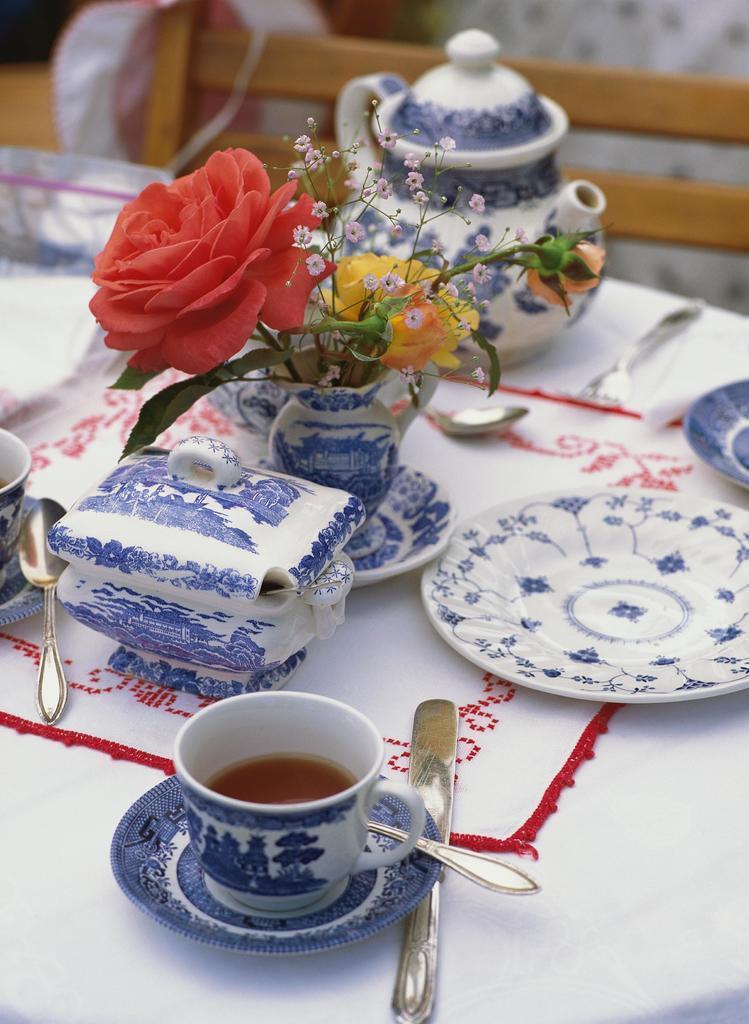How would you summarize this image in a sentence or two? In this picture i could see a dining table on dining table there are tea cups and a saucer and in the saucer there is spoon and beside the saucer there is a knife. There is sugar can and a flower pot with flowers in it, there is a teapot beside the flower pot and a chair in the back of the dining table. 